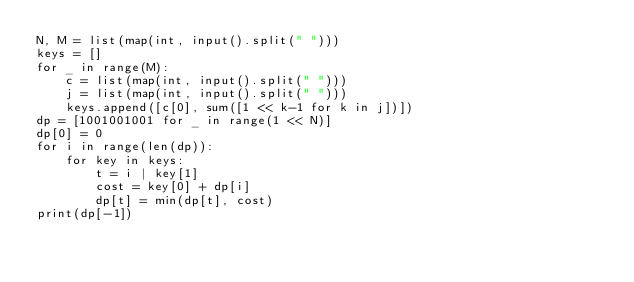Convert code to text. <code><loc_0><loc_0><loc_500><loc_500><_Python_>N, M = list(map(int, input().split(" ")))
keys = []
for _ in range(M):
	c = list(map(int, input().split(" ")))
	j = list(map(int, input().split(" ")))
	keys.append([c[0], sum([1 << k-1 for k in j])])
dp = [1001001001 for _ in range(1 << N)]
dp[0] = 0
for i in range(len(dp)):
    for key in keys:
        t = i | key[1]
        cost = key[0] + dp[i]
        dp[t] = min(dp[t], cost)
print(dp[-1])</code> 